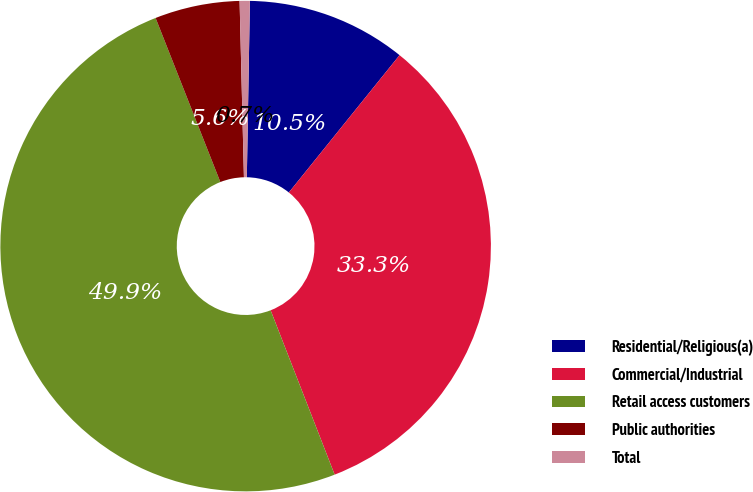<chart> <loc_0><loc_0><loc_500><loc_500><pie_chart><fcel>Residential/Religious(a)<fcel>Commercial/Industrial<fcel>Retail access customers<fcel>Public authorities<fcel>Total<nl><fcel>10.52%<fcel>33.29%<fcel>49.93%<fcel>5.59%<fcel>0.67%<nl></chart> 